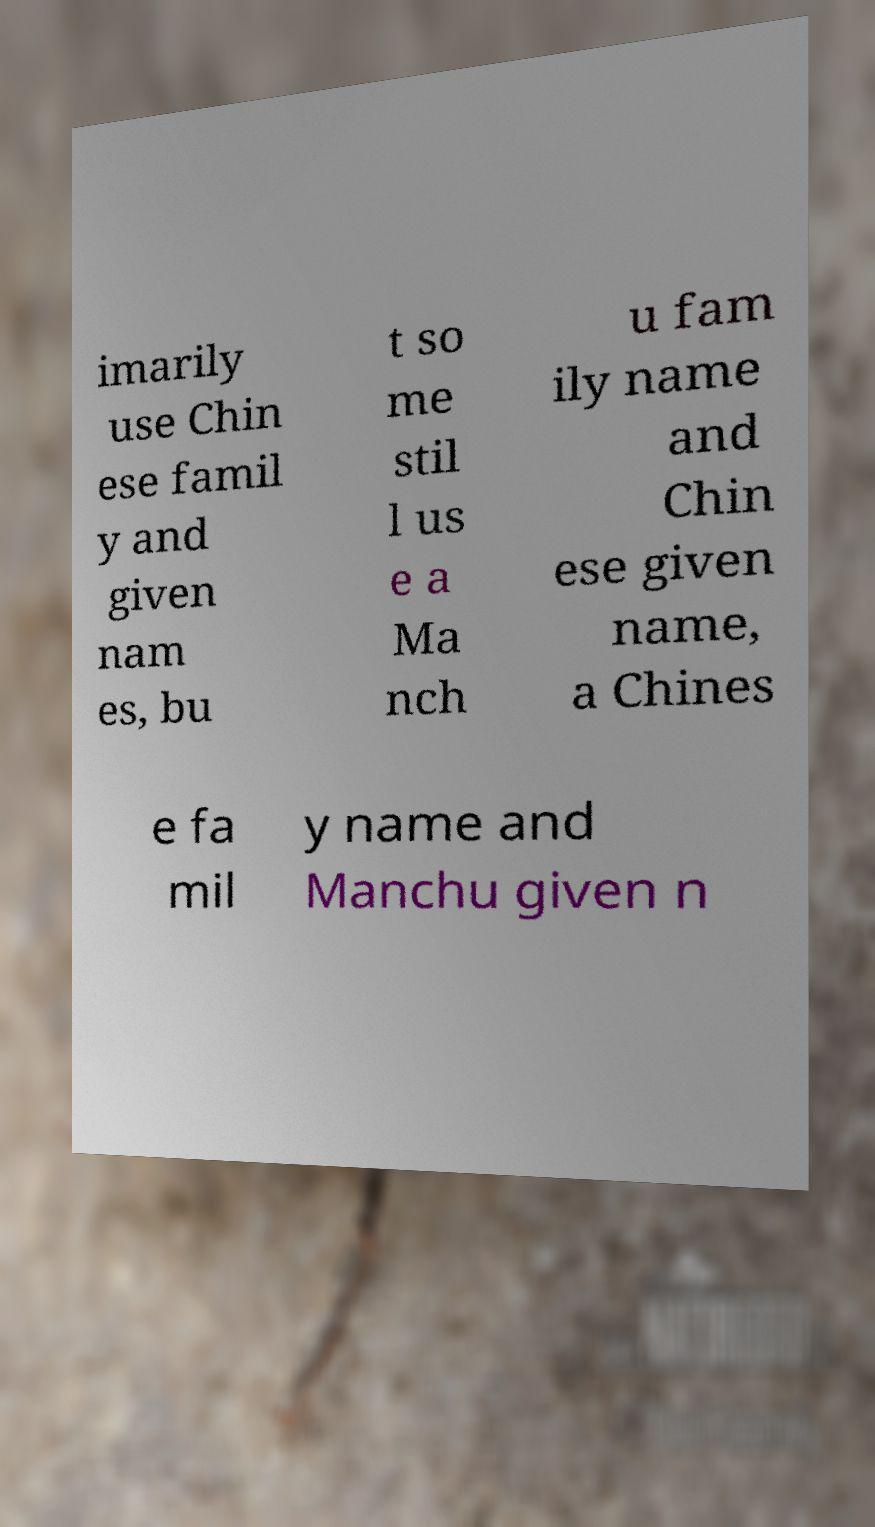Could you extract and type out the text from this image? imarily use Chin ese famil y and given nam es, bu t so me stil l us e a Ma nch u fam ily name and Chin ese given name, a Chines e fa mil y name and Manchu given n 